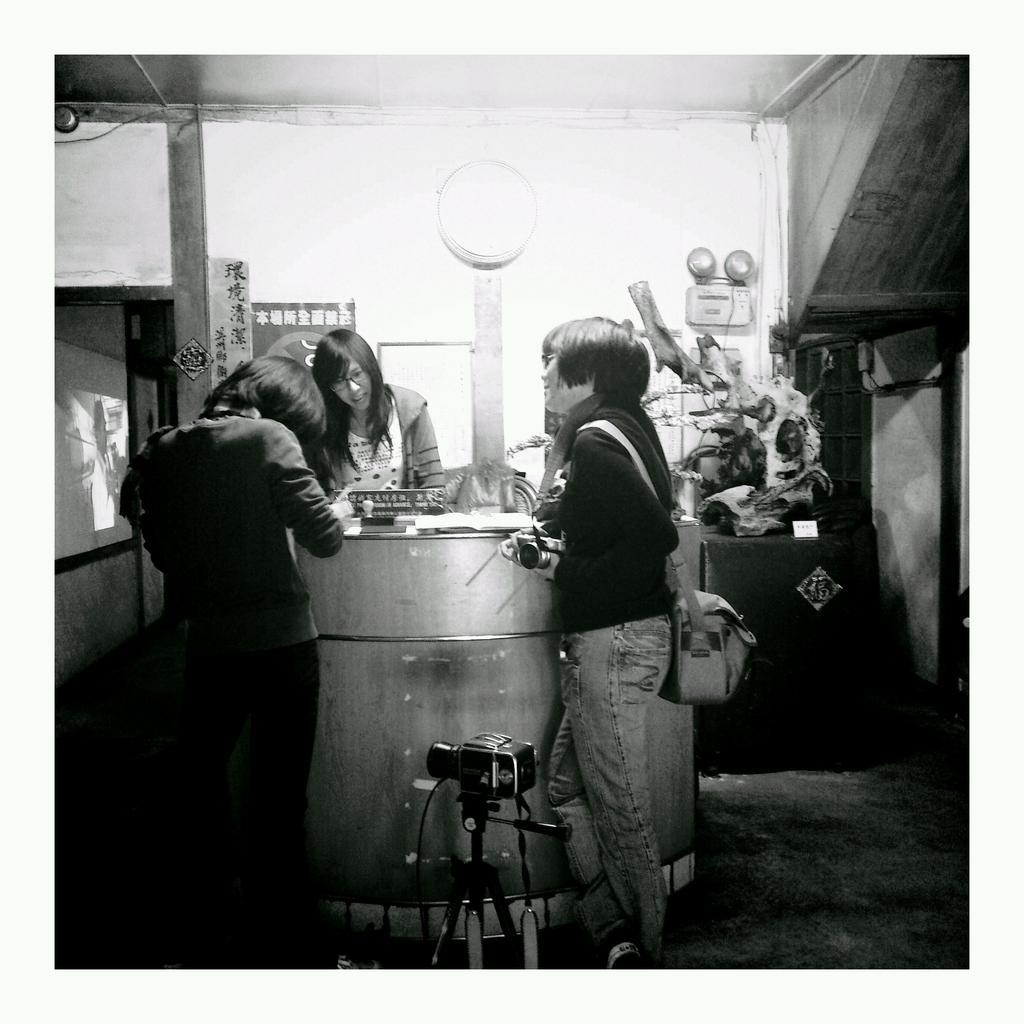Describe this image in one or two sentences. In this image I can see the black and white picture in which I can see the camera, the floor, few persons standing, a person wearing a bag, the wall, the ceiling and few other objects. 